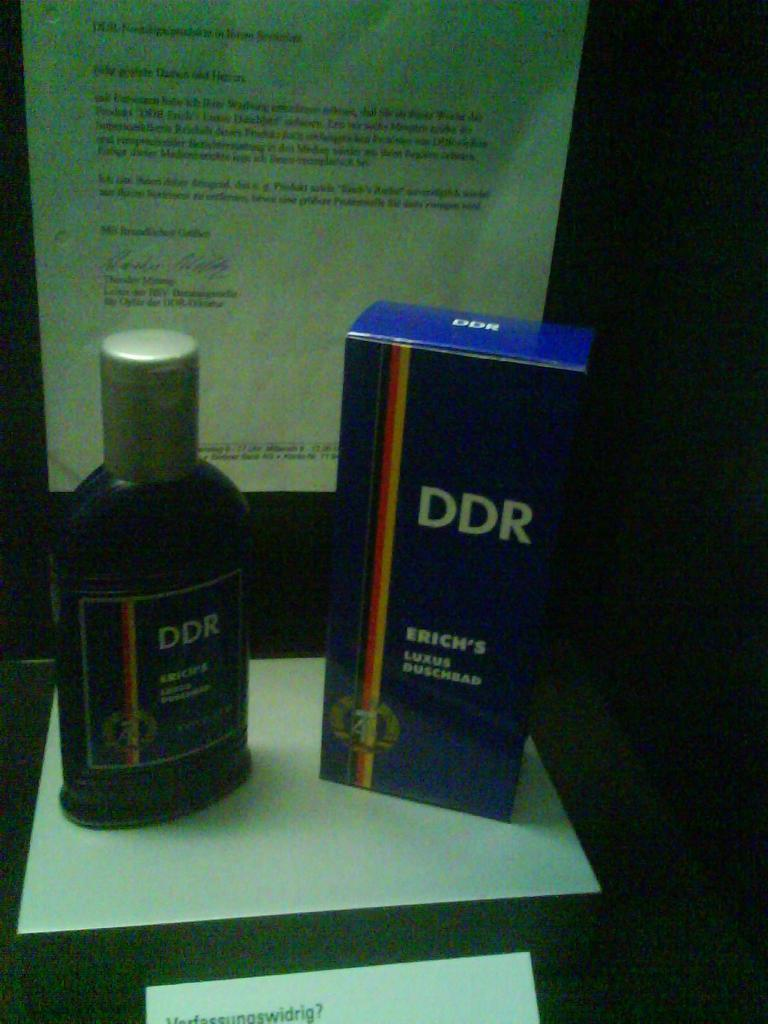<image>
Write a terse but informative summary of the picture. A bottle of "DDR Luxus Duschbad" sits next to its box in front of a letter. 